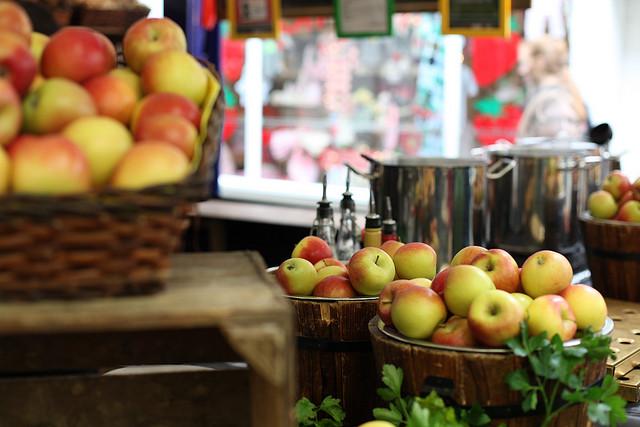How many types of fruit are there?
Keep it brief. 1. What is in the basket?
Be succinct. Apples. Are there people in this shot?
Concise answer only. Yes. What is the fruit in?
Short answer required. Basket. Can these fruit be prepared for pies?
Keep it brief. Yes. 